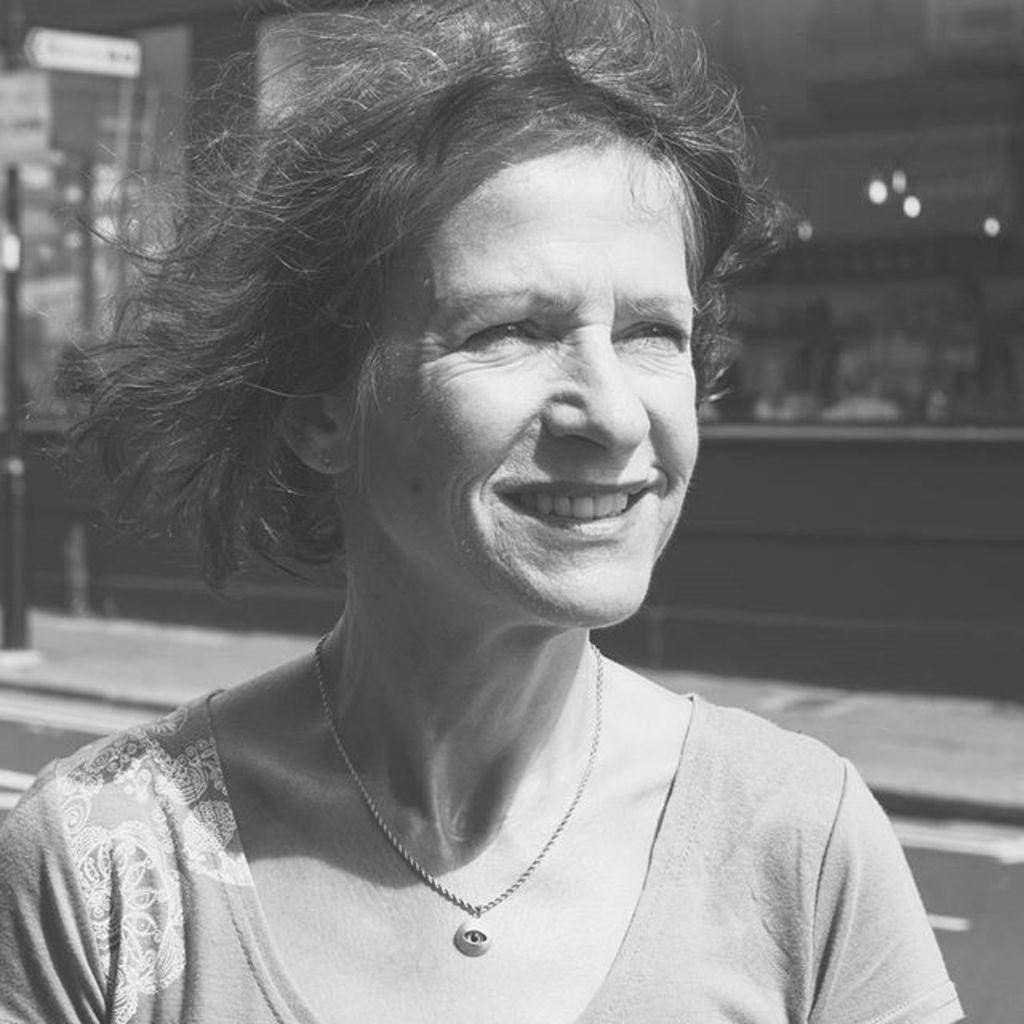Could you give a brief overview of what you see in this image? In this image I can see a women and I can see she is wearing necklace and top. I can also see smile on her face and I can see this image is black and white in colour. 